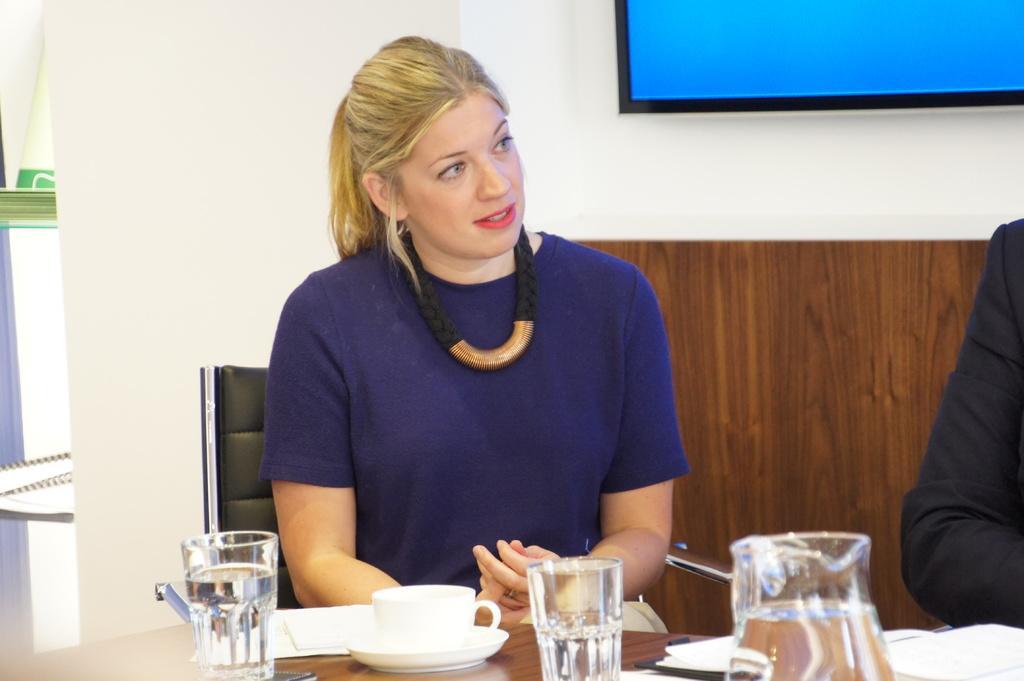Describe this image in one or two sentences. The image is inside the room. In the image there is a woman wearing a blue color shirt sitting on chair in front of a table, on table we can see a glass,coffee cup,jar,papers. In background there is a monitor and a wall which is in white color. 